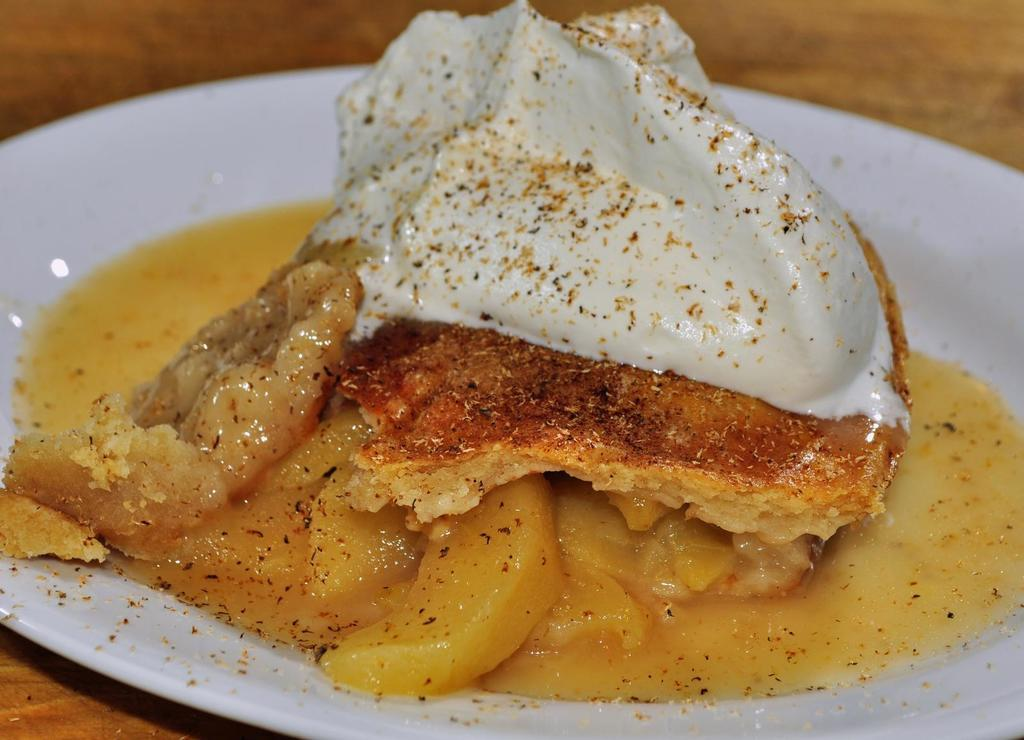What is the color of the plate in the image? The plate in the image is white. What is on the plate? There are food items on the plate. What is the plate resting on? The plate is placed on a wooden surface. How would you describe the image's clarity? The image is blurred. How many ants are crawling on the lock in the image? There is no lock or ants present in the image. 